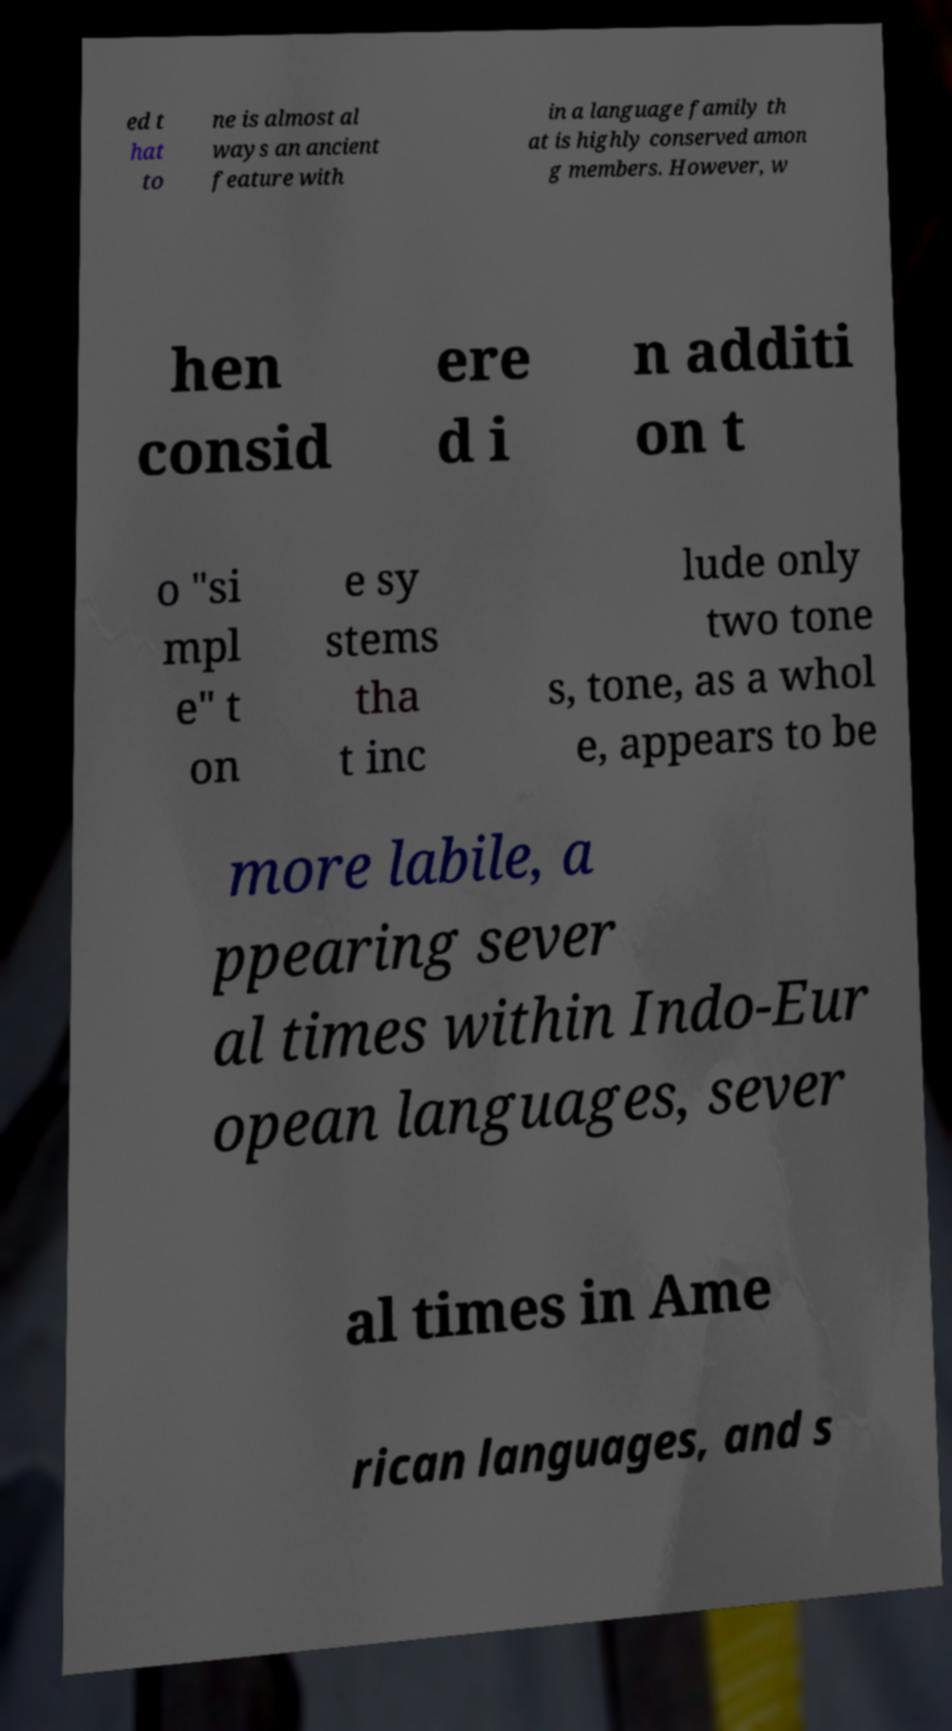Please identify and transcribe the text found in this image. ed t hat to ne is almost al ways an ancient feature with in a language family th at is highly conserved amon g members. However, w hen consid ere d i n additi on t o "si mpl e" t on e sy stems tha t inc lude only two tone s, tone, as a whol e, appears to be more labile, a ppearing sever al times within Indo-Eur opean languages, sever al times in Ame rican languages, and s 